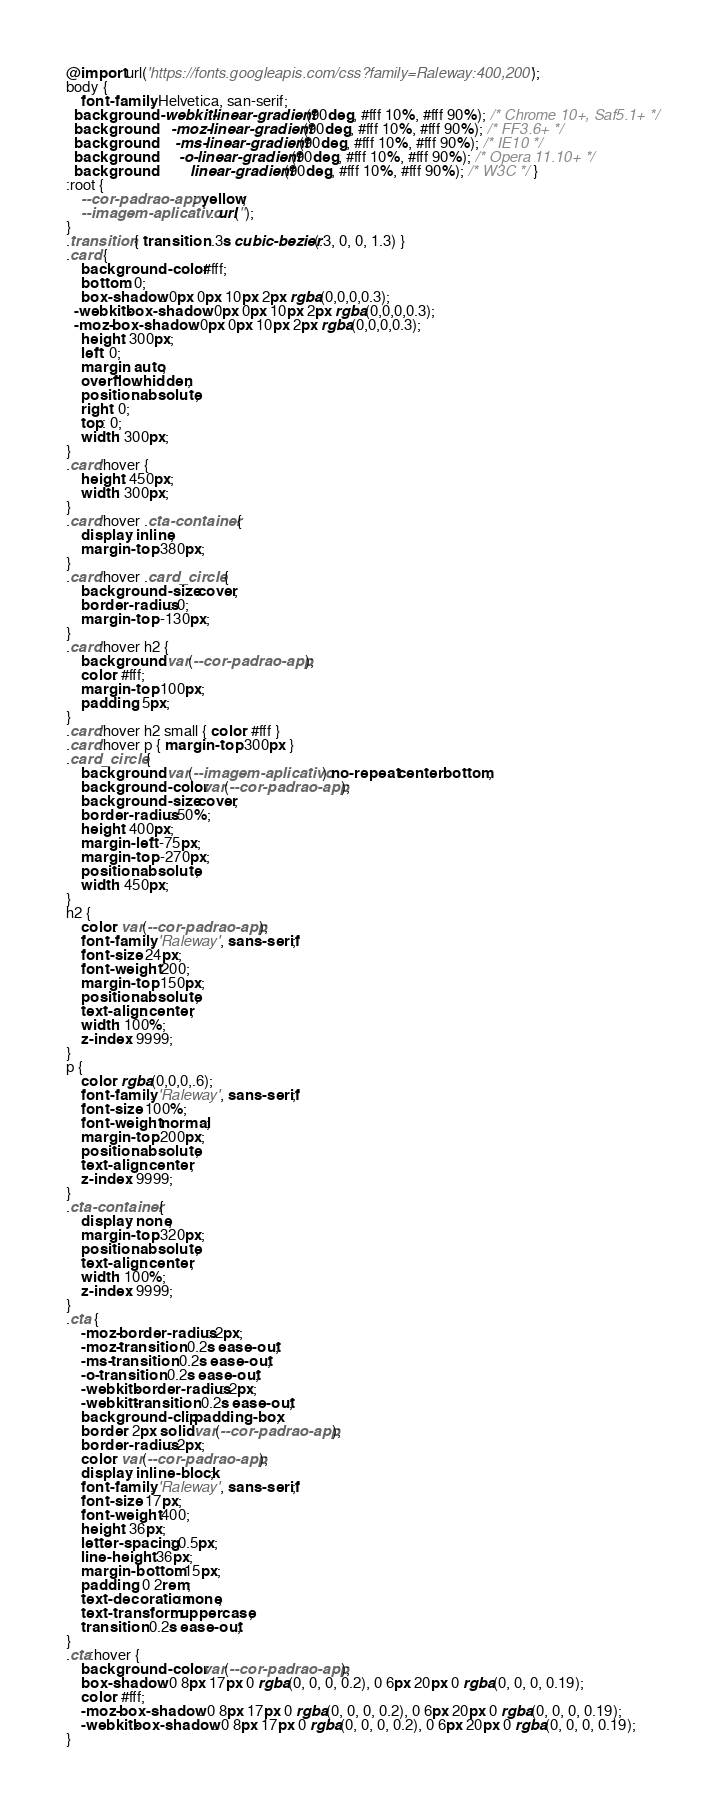Convert code to text. <code><loc_0><loc_0><loc_500><loc_500><_CSS_>@import url('https://fonts.googleapis.com/css?family=Raleway:400,200');
body {   
	font-family: Helvetica, san-serif;
  background: -webkit-linear-gradient(90deg, #fff 10%, #fff 90%); /* Chrome 10+, Saf5.1+ */
  background:    -moz-linear-gradient(90deg, #fff 10%, #fff 90%); /* FF3.6+ */
  background:     -ms-linear-gradient(90deg, #fff 10%, #fff 90%); /* IE10 */
  background:      -o-linear-gradient(90deg, #fff 10%, #fff 90%); /* Opera 11.10+ */
  background:         linear-gradient(90deg, #fff 10%, #fff 90%); /* W3C */ }
:root {
	--cor-padrao-app: yellow;
	--imagem-aplicativo: url('');
}
.transition { transition: .3s cubic-bezier(.3, 0, 0, 1.3) }
.card {
    background-color: #fff;
    bottom: 0;
    box-shadow: 0px 0px 10px 2px rgba(0,0,0,0.3);
  -webkit-box-shadow: 0px 0px 10px 2px rgba(0,0,0,0.3);
  -moz-box-shadow: 0px 0px 10px 2px rgba(0,0,0,0.3);
    height: 300px;
    left: 0;
    margin: auto;
    overflow: hidden;
    position: absolute;
    right: 0;
    top: 0;
    width: 300px;
}
.card:hover {
    height: 450px;
    width: 300px;
}
.card:hover .cta-container {
    display: inline;
    margin-top: 380px;
}
.card:hover .card_circle {
    background-size: cover;
    border-radius: 0;
    margin-top: -130px;
}
.card:hover h2 {
    background: var(--cor-padrao-app);
    color: #fff;
    margin-top: 100px;
    padding: 5px;
}
.card:hover h2 small { color: #fff }
.card:hover p { margin-top: 300px }
.card_circle {
    background: var(--imagem-aplicativo) no-repeat center bottom;
    background-color: var(--cor-padrao-app);
    background-size: cover;
    border-radius: 50%;
    height: 400px;
    margin-left: -75px;
    margin-top: -270px;
    position: absolute;
    width: 450px;
}
h2 {
    color: var(--cor-padrao-app);
    font-family: 'Raleway', sans-serif;
    font-size: 24px;
    font-weight: 200;
    margin-top: 150px;
    position: absolute;
    text-align: center;
    width: 100%;
    z-index: 9999;
}
p {
    color: rgba(0,0,0,.6);
    font-family: 'Raleway', sans-serif;
    font-size: 100%;
    font-weight: normal;
    margin-top: 200px;
    position: absolute;
    text-align: center;
    z-index: 9999;
}
.cta-container {
    display: none;
    margin-top: 320px;
    position: absolute;
    text-align: center;
    width: 100%;
    z-index: 9999;
}
.cta {
    -moz-border-radius: 2px;
    -moz-transition: 0.2s ease-out;
    -ms-transition: 0.2s ease-out;
    -o-transition: 0.2s ease-out;
    -webkit-border-radius: 2px;
    -webkit-transition: 0.2s ease-out;
    background-clip: padding-box;
    border: 2px solid var(--cor-padrao-app);
    border-radius: 2px;
    color: var(--cor-padrao-app);
    display: inline-block;
    font-family: 'Raleway', sans-serif;
    font-size: 17px;
    font-weight: 400;
    height: 36px;
    letter-spacing: 0.5px;
    line-height: 36px;
    margin-bottom: 15px;
    padding: 0 2rem;
    text-decoration: none;
    text-transform: uppercase;
    transition: 0.2s ease-out;
}
.cta:hover {
    background-color: var(--cor-padrao-app);
    box-shadow: 0 8px 17px 0 rgba(0, 0, 0, 0.2), 0 6px 20px 0 rgba(0, 0, 0, 0.19);
    color: #fff;
    -moz-box-shadow: 0 8px 17px 0 rgba(0, 0, 0, 0.2), 0 6px 20px 0 rgba(0, 0, 0, 0.19);
    -webkit-box-shadow: 0 8px 17px 0 rgba(0, 0, 0, 0.2), 0 6px 20px 0 rgba(0, 0, 0, 0.19);
}</code> 